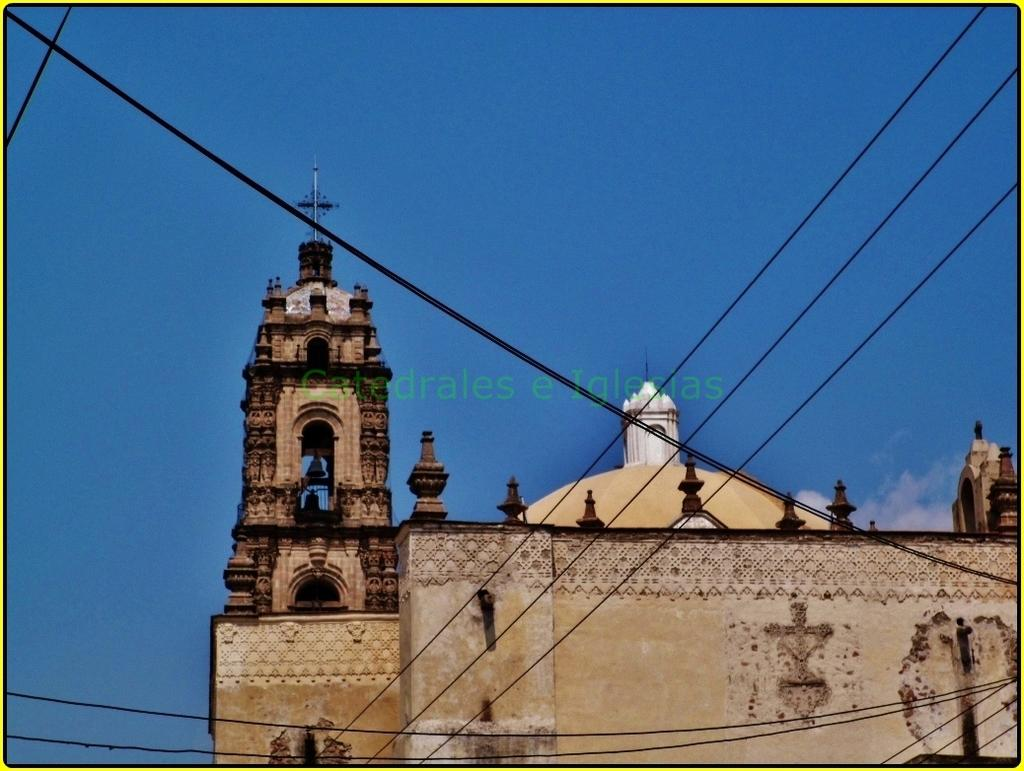What type of structure is located at the bottom of the image? There is a building at the bottom of the image. What can be seen in the foreground of the image? There are wires in the foreground of the image. What is visible at the top of the image? The sky is visible at the top of the image. How many cubs are playing in the image? There are no cubs present in the image. What type of flock is flying in the sky? There is no flock flying in the sky; only the sky is visible. 